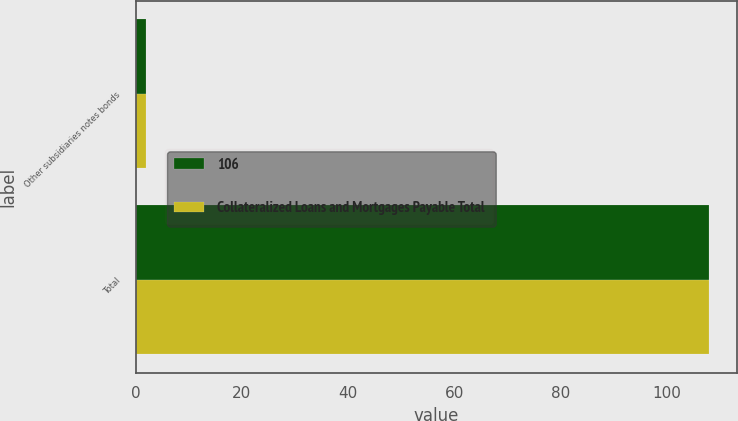<chart> <loc_0><loc_0><loc_500><loc_500><stacked_bar_chart><ecel><fcel>Other subsidiaries notes bonds<fcel>Total<nl><fcel>106<fcel>2<fcel>108<nl><fcel>Collateralized Loans and Mortgages Payable Total<fcel>2<fcel>108<nl></chart> 